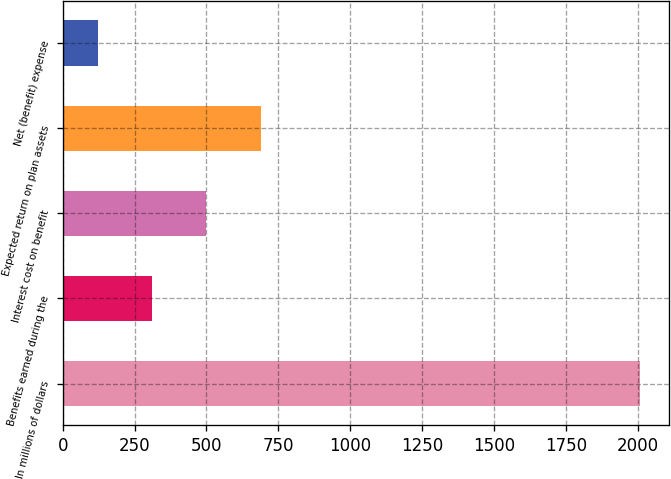Convert chart to OTSL. <chart><loc_0><loc_0><loc_500><loc_500><bar_chart><fcel>In millions of dollars<fcel>Benefits earned during the<fcel>Interest cost on benefit<fcel>Expected return on plan assets<fcel>Net (benefit) expense<nl><fcel>2007<fcel>311.4<fcel>499.8<fcel>688.2<fcel>123<nl></chart> 